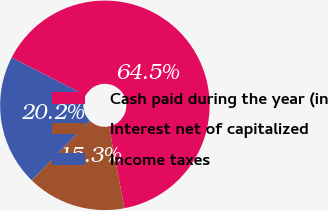<chart> <loc_0><loc_0><loc_500><loc_500><pie_chart><fcel>Cash paid during the year (in<fcel>Interest net of capitalized<fcel>Income taxes<nl><fcel>64.47%<fcel>15.31%<fcel>20.22%<nl></chart> 